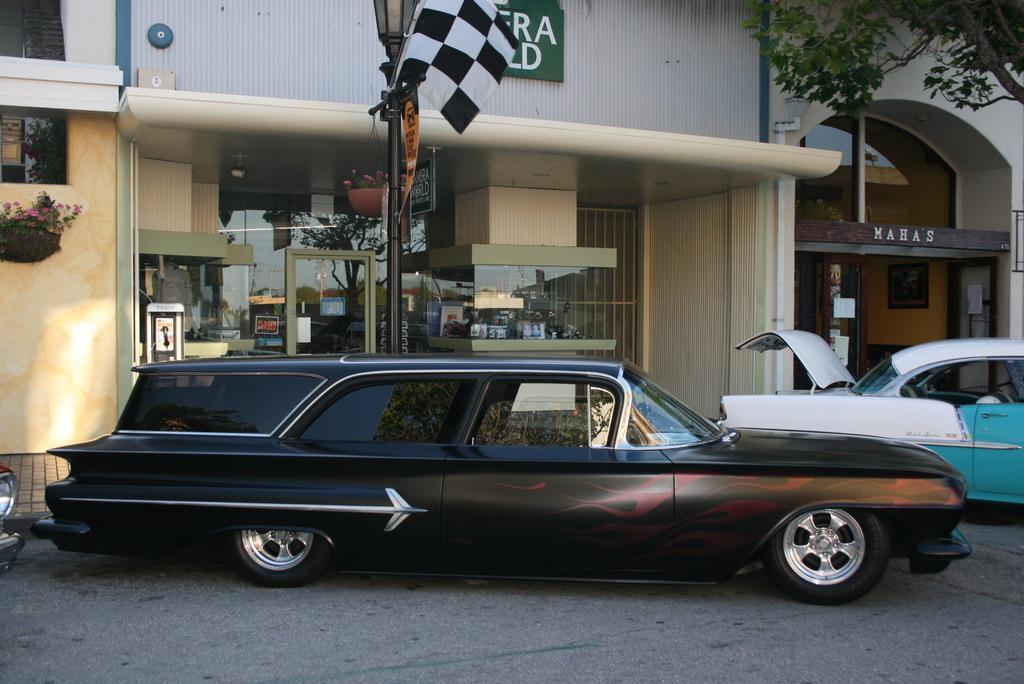Can you describe this image briefly? In this picture I can see vehicles on the road, there are buildings, there is a light with a pole, there are plants, boards, flag and there is a tree. 